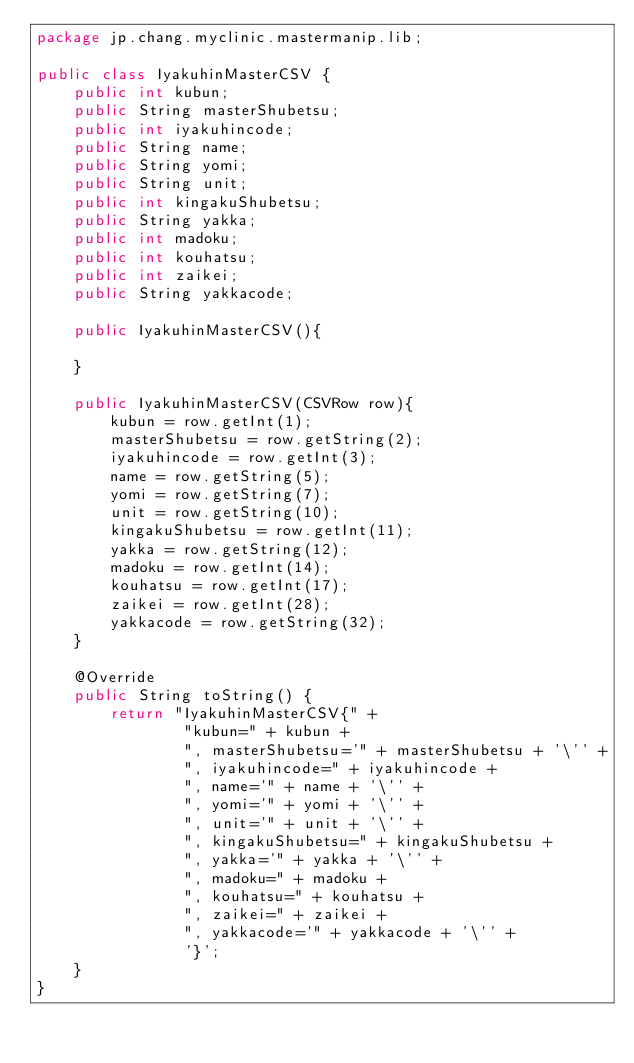<code> <loc_0><loc_0><loc_500><loc_500><_Java_>package jp.chang.myclinic.mastermanip.lib;

public class IyakuhinMasterCSV {
    public int kubun;
    public String masterShubetsu;
    public int iyakuhincode;
    public String name;
    public String yomi;
    public String unit;
    public int kingakuShubetsu;
    public String yakka;
    public int madoku;
    public int kouhatsu;
    public int zaikei;
    public String yakkacode;

    public IyakuhinMasterCSV(){

    }

    public IyakuhinMasterCSV(CSVRow row){
        kubun = row.getInt(1);
        masterShubetsu = row.getString(2);
        iyakuhincode = row.getInt(3);
        name = row.getString(5);
        yomi = row.getString(7);
        unit = row.getString(10);
        kingakuShubetsu = row.getInt(11);
        yakka = row.getString(12);
        madoku = row.getInt(14);
        kouhatsu = row.getInt(17);
        zaikei = row.getInt(28);
        yakkacode = row.getString(32);
    }

    @Override
    public String toString() {
        return "IyakuhinMasterCSV{" +
                "kubun=" + kubun +
                ", masterShubetsu='" + masterShubetsu + '\'' +
                ", iyakuhincode=" + iyakuhincode +
                ", name='" + name + '\'' +
                ", yomi='" + yomi + '\'' +
                ", unit='" + unit + '\'' +
                ", kingakuShubetsu=" + kingakuShubetsu +
                ", yakka='" + yakka + '\'' +
                ", madoku=" + madoku +
                ", kouhatsu=" + kouhatsu +
                ", zaikei=" + zaikei +
                ", yakkacode='" + yakkacode + '\'' +
                '}';
    }
}

</code> 